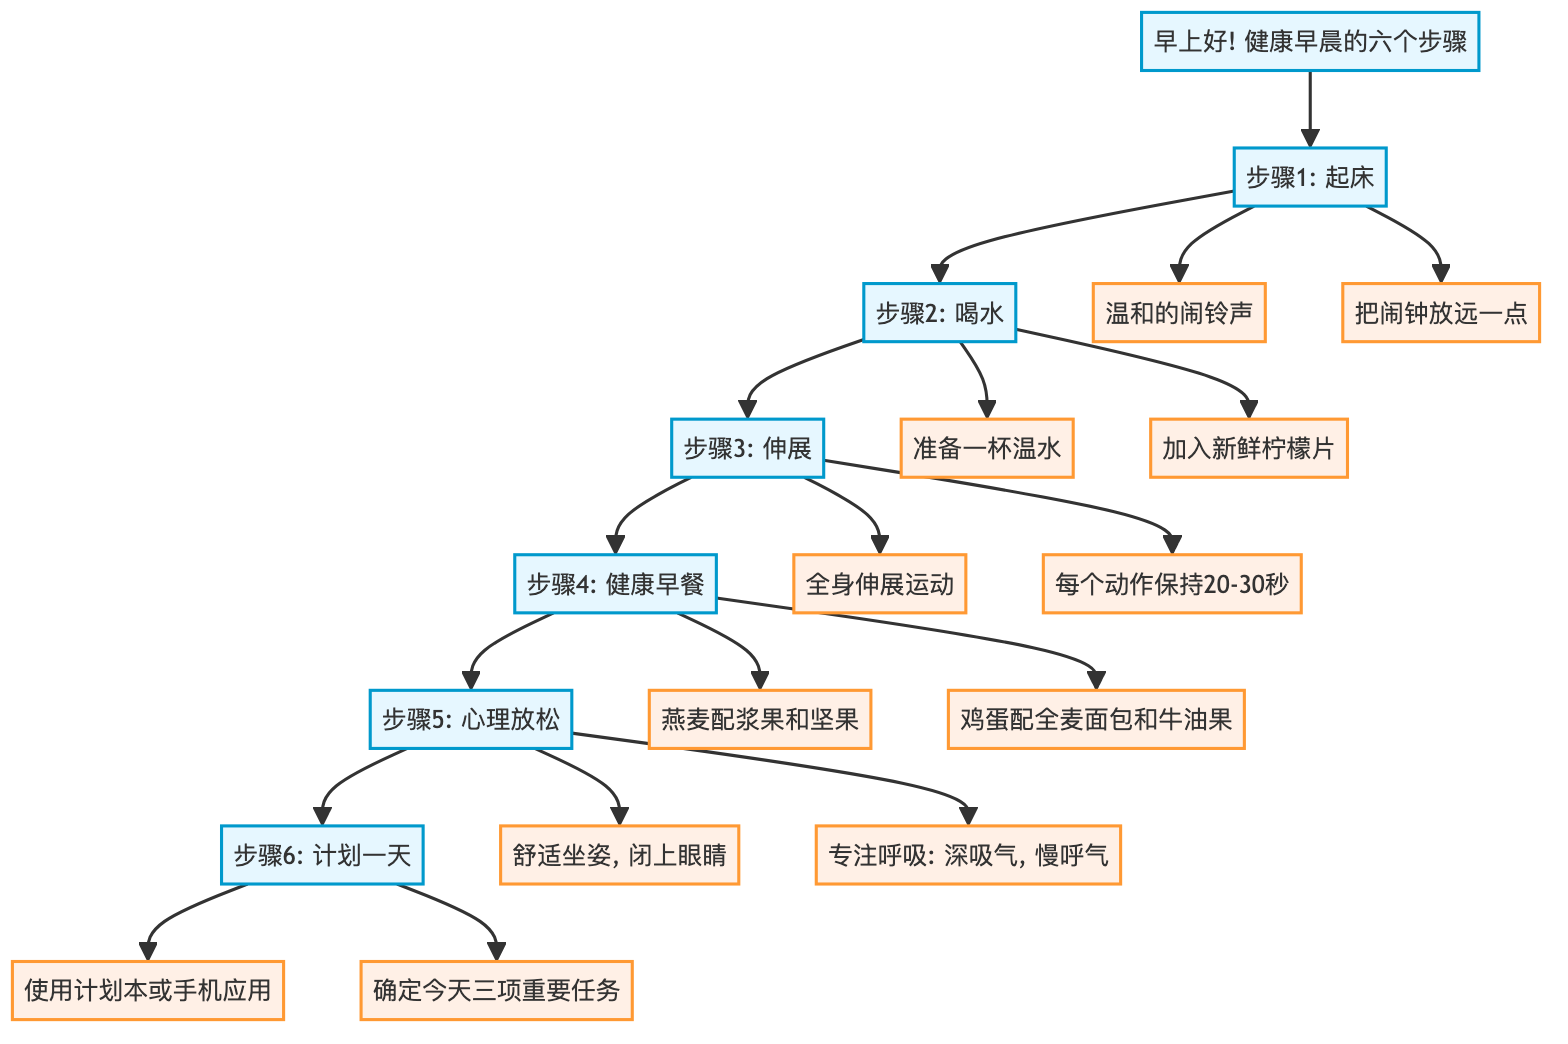What is the first step in the healthy morning routine? The first step listed in the diagram is "Wake Up." It is represented as the initial node, which signifies the starting point of the morning routine.
Answer: Wake Up How many total steps are shown in the diagram? The diagram includes six distinct steps, each representing a part of the healthy morning routine. Since there are six main nodes from "Wake Up" to "Plan Your Day," the total is six.
Answer: 6 Which step involves drinking water? The step that involves drinking water is "Hydrate," which follows "Wake Up" in the flow of the diagram. This step specifically describes the action of consuming water.
Answer: Hydrate What does the "Healthy Breakfast" step recommend? The "Healthy Breakfast" step recommends having a balanced meal, mentioning specific food items such as oatmeal with berries and nuts, or eggs with whole grain toast and avocado.
Answer: Oatmeal with berries and nuts; Eggs with whole grain toast and avocado What is the last step in the process? The last step in the healthy morning routine flowchart is "Plan Your Day," which is the concluding action after completing all previous steps.
Answer: Plan Your Day Which two key points are associated with the "Stretch" step? The "Stretch" step lists two key points: focusing on full-body stretches and holding each stretch for 20-30 seconds. These details help clarify how to execute this step effectively.
Answer: Full-body stretches; Hold each stretch for 20-30 seconds How do the steps relate to each other? The steps are structured in a sequential flow, where each step leads to the next. For instance, after "Wake Up," you proceed to "Hydrate," and then to "Stretch," showing a clear progression of actions for a healthy morning routine.
Answer: Sequential flow What is the primary purpose of the "Mental Relaxation" step? The primary purpose of the "Mental Relaxation" step is to reduce stress, focusing on taking 10 minutes to meditate or practice deep breathing in a quiet place, as indicated in the description.
Answer: Reduce stress 